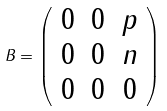Convert formula to latex. <formula><loc_0><loc_0><loc_500><loc_500>B = \left ( \begin{array} { c c c } 0 & 0 & p \\ 0 & 0 & n \\ 0 & 0 & 0 \end{array} \right )</formula> 